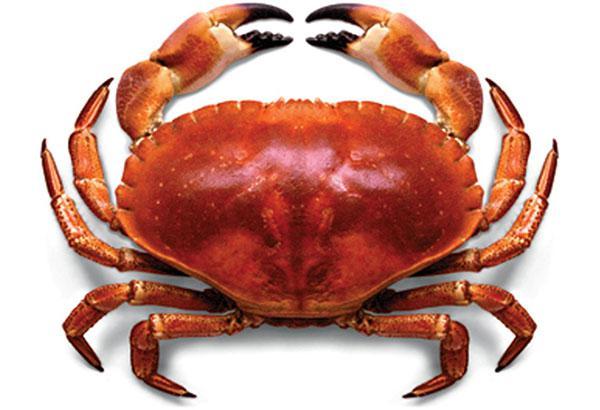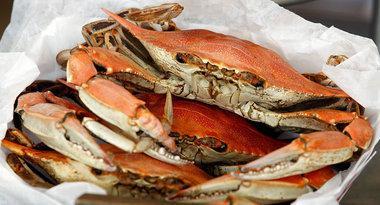The first image is the image on the left, the second image is the image on the right. Analyze the images presented: Is the assertion "One image contains a single red-orange crab with an intact red-orange shell and claws, and the other image includes multiple crabs on a white container surface." valid? Answer yes or no. Yes. The first image is the image on the left, the second image is the image on the right. For the images shown, is this caption "At least one of the crabs has black tipped pincers." true? Answer yes or no. Yes. 